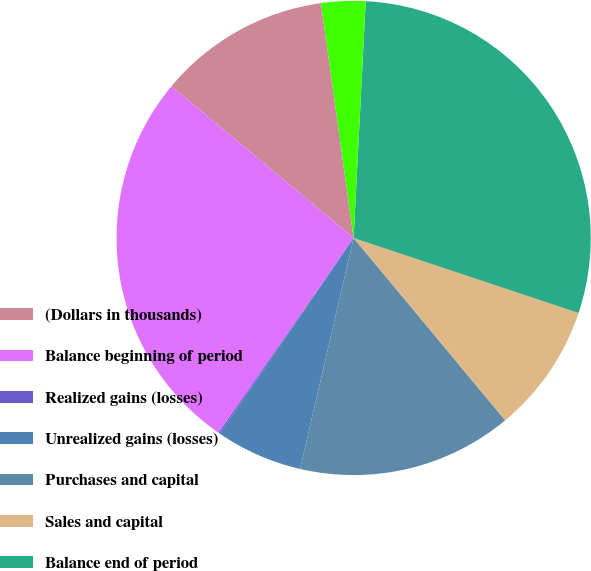Convert chart. <chart><loc_0><loc_0><loc_500><loc_500><pie_chart><fcel>(Dollars in thousands)<fcel>Balance beginning of period<fcel>Realized gains (losses)<fcel>Unrealized gains (losses)<fcel>Purchases and capital<fcel>Sales and capital<fcel>Balance end of period<fcel>relating to assets still held<nl><fcel>11.75%<fcel>26.4%<fcel>0.1%<fcel>5.92%<fcel>14.66%<fcel>8.84%<fcel>29.31%<fcel>3.01%<nl></chart> 